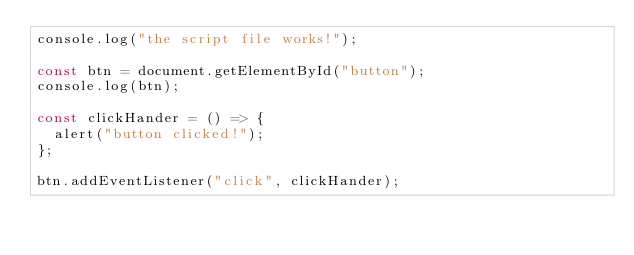<code> <loc_0><loc_0><loc_500><loc_500><_JavaScript_>console.log("the script file works!");

const btn = document.getElementById("button");
console.log(btn);

const clickHander = () => {
  alert("button clicked!");
};

btn.addEventListener("click", clickHander);
</code> 